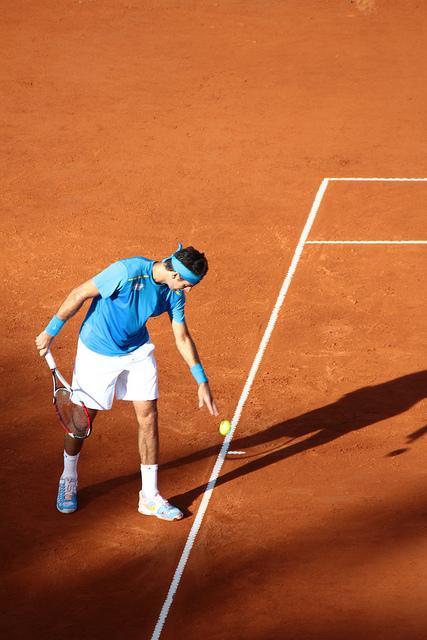What is the guy bouncing?
Keep it brief. Tennis ball. Is this a clay court?
Quick response, please. Yes. Is a shadow cast?
Answer briefly. Yes. 